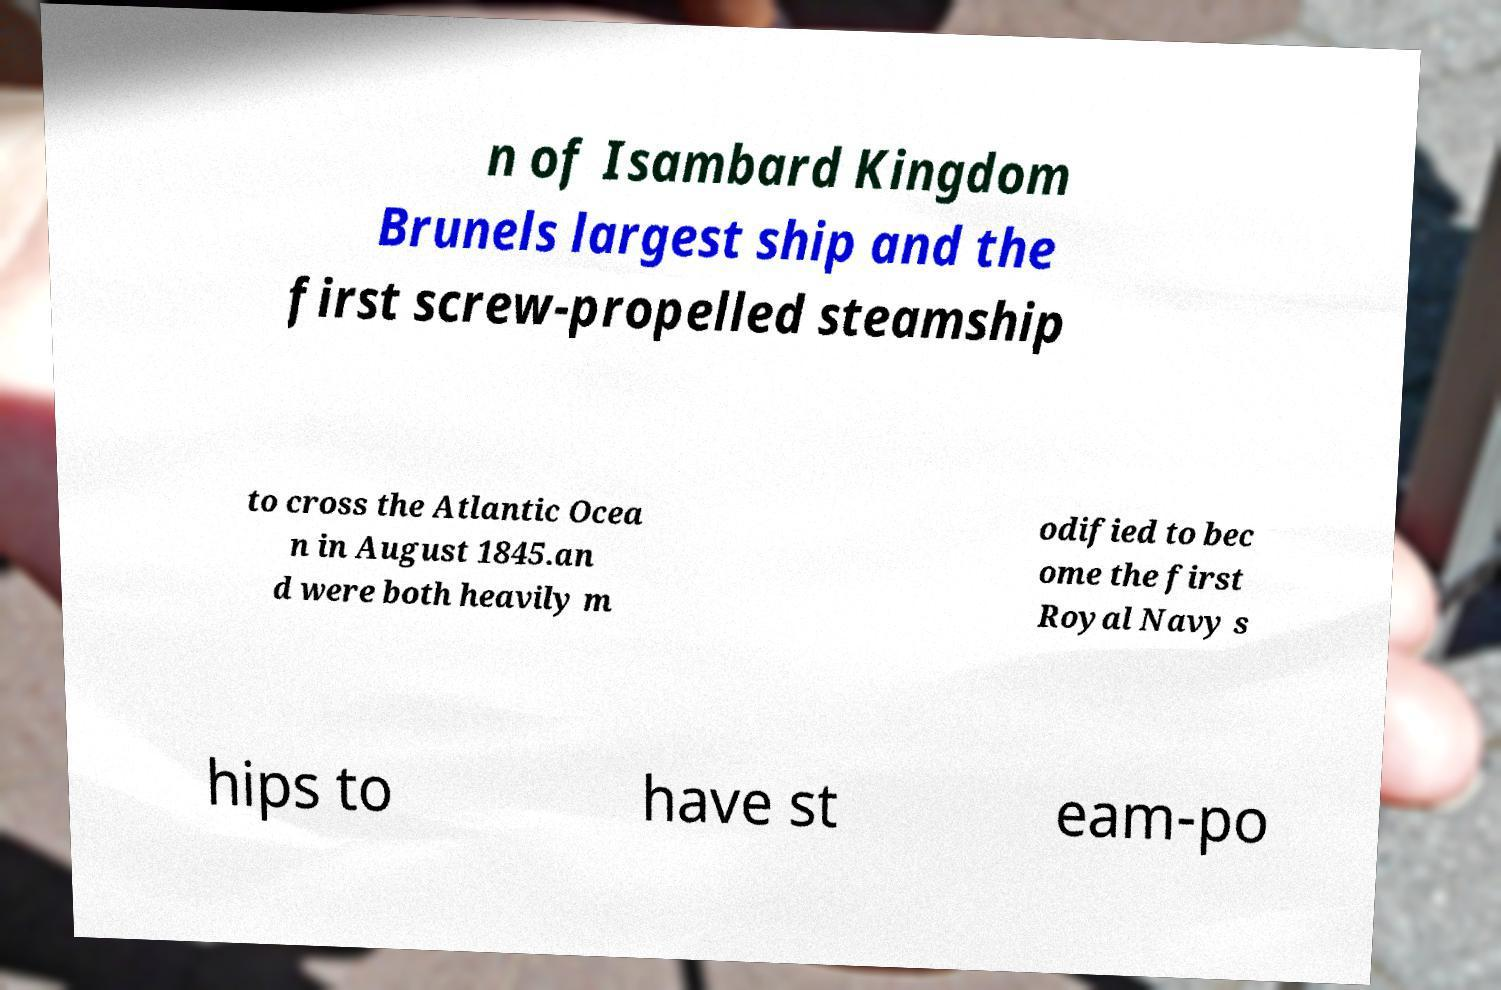I need the written content from this picture converted into text. Can you do that? n of Isambard Kingdom Brunels largest ship and the first screw-propelled steamship to cross the Atlantic Ocea n in August 1845.an d were both heavily m odified to bec ome the first Royal Navy s hips to have st eam-po 